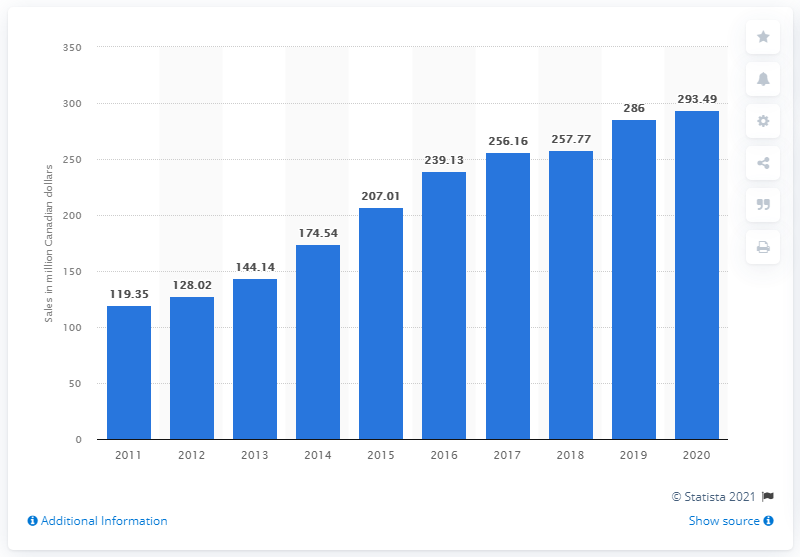Identify some key points in this picture. The sales value of cider in Canada during the fiscal year ending March 31, 2020 was CAD 293.49. 